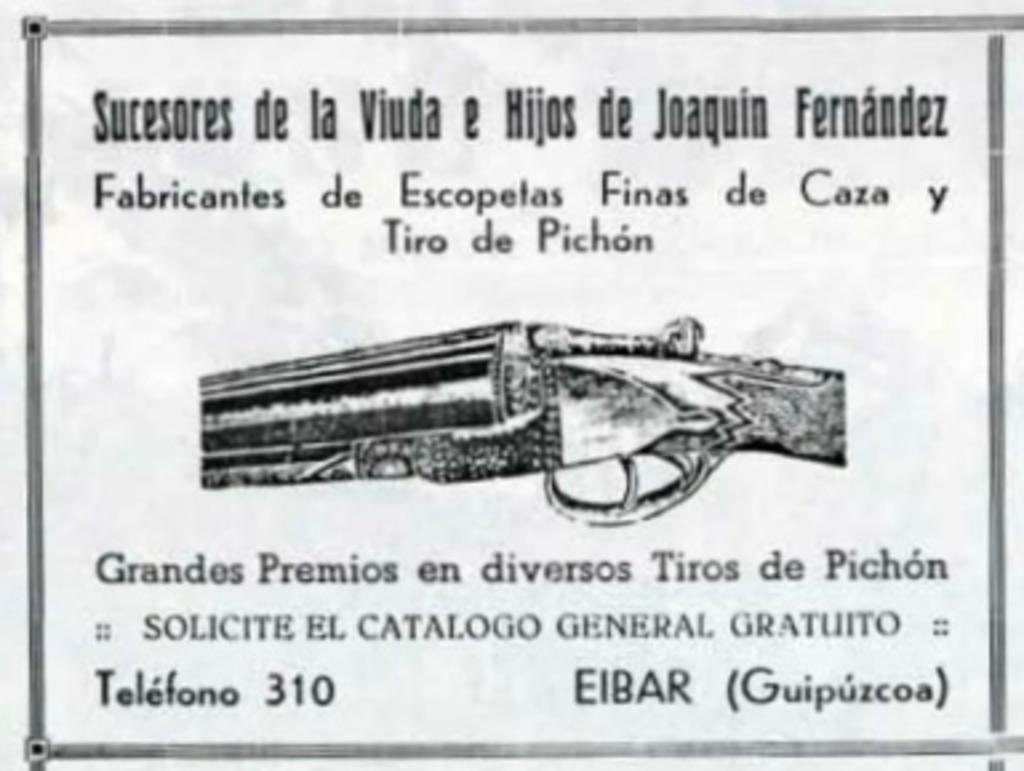What is present in the image that can be written on? There is a paper in the image that can be written on. What can be seen on the paper? Something is written on the paper, and there is a picture of a gun. What type of industry can be seen in the background of the image? There is no industry visible in the image; it only features a paper with writing and a picture of a gun. 